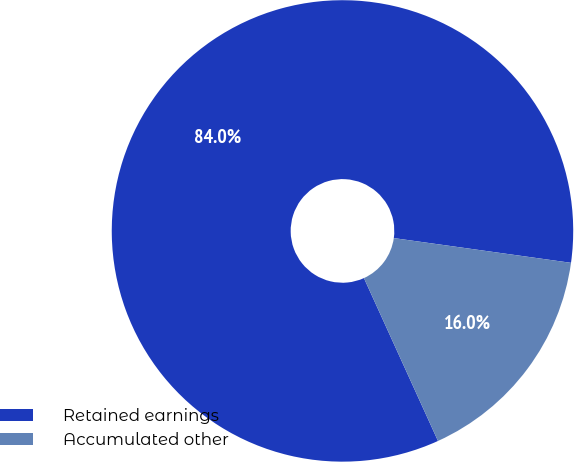<chart> <loc_0><loc_0><loc_500><loc_500><pie_chart><fcel>Retained earnings<fcel>Accumulated other<nl><fcel>84.0%<fcel>16.0%<nl></chart> 